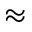<formula> <loc_0><loc_0><loc_500><loc_500>\approx</formula> 